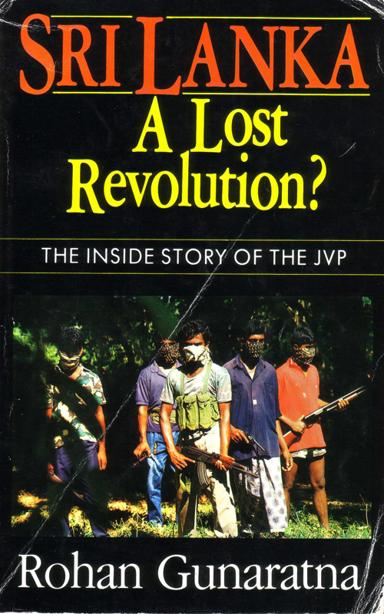Who is the author of the book? The author of the book shown in the image is Rohan Gunaratna. He is a respected expert on security and terrorism issues, particularly focusing on conflicts within South Asia. His work on the JVP provides crucial insights into this significant yet turbulent chapter of Sri Lanka's history. 